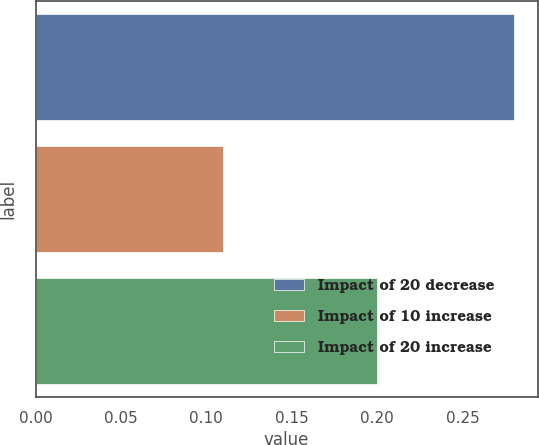<chart> <loc_0><loc_0><loc_500><loc_500><bar_chart><fcel>Impact of 20 decrease<fcel>Impact of 10 increase<fcel>Impact of 20 increase<nl><fcel>0.28<fcel>0.11<fcel>0.2<nl></chart> 